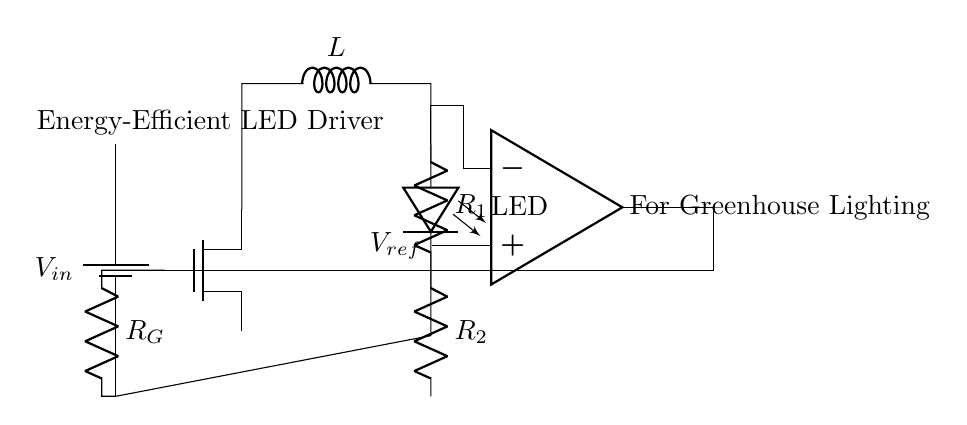What is the power supply used in the circuit? The power supply used in the circuit is a battery, indicated by the symbol for a battery in the diagram and labeled as V_in.
Answer: Battery What type of MOSFET is shown in the diagram? The circuit features an n-channel MOSFET, identified by the notation "nmos" next to the corresponding symbol, indicating its type based on the schematic convention.
Answer: N-channel What component is connected to the output of the MOSFET? The output of the MOSFET is connected to an inductor, shown by the inductance symbol L immediately following the MOSFET in the diagram.
Answer: Inductor How many feedback resistors are present in the circuit? There are two feedback resistors in the circuit, labeled R_1 and R_2, which are drawn in series as indicated in the diagram.
Answer: Two What is the function of the operational amplifier in this circuit? The operational amplifier is used for voltage control in the circuit. It compares the feedback voltage from R_1 and R_2 with a reference voltage, V_ref, to control the gate of the MOSFET, adjusting the current through the LED accordingly.
Answer: Voltage control What does V_ref represent in this driver circuit? V_ref represents the reference voltage that the operational amplifier compares against the voltage from the feedback network (R_1 and R_2) to regulate the LED brightness effectively.
Answer: Reference voltage What is the purpose of the resistor R_G in the circuit? The resistor R_G is connected to the gate of the MOSFET and serves to control the gate current, ensuring that the MOSFET operates efficiently in response to the signals from the operational amplifier.
Answer: Gate current control 